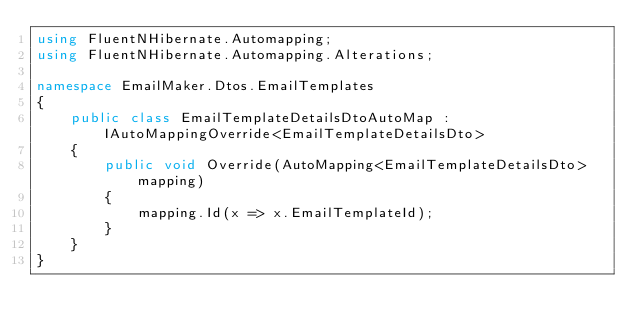<code> <loc_0><loc_0><loc_500><loc_500><_C#_>using FluentNHibernate.Automapping;
using FluentNHibernate.Automapping.Alterations;

namespace EmailMaker.Dtos.EmailTemplates
{
    public class EmailTemplateDetailsDtoAutoMap : IAutoMappingOverride<EmailTemplateDetailsDto>
    {
        public void Override(AutoMapping<EmailTemplateDetailsDto> mapping)
        {
            mapping.Id(x => x.EmailTemplateId);
        }
    }
}</code> 